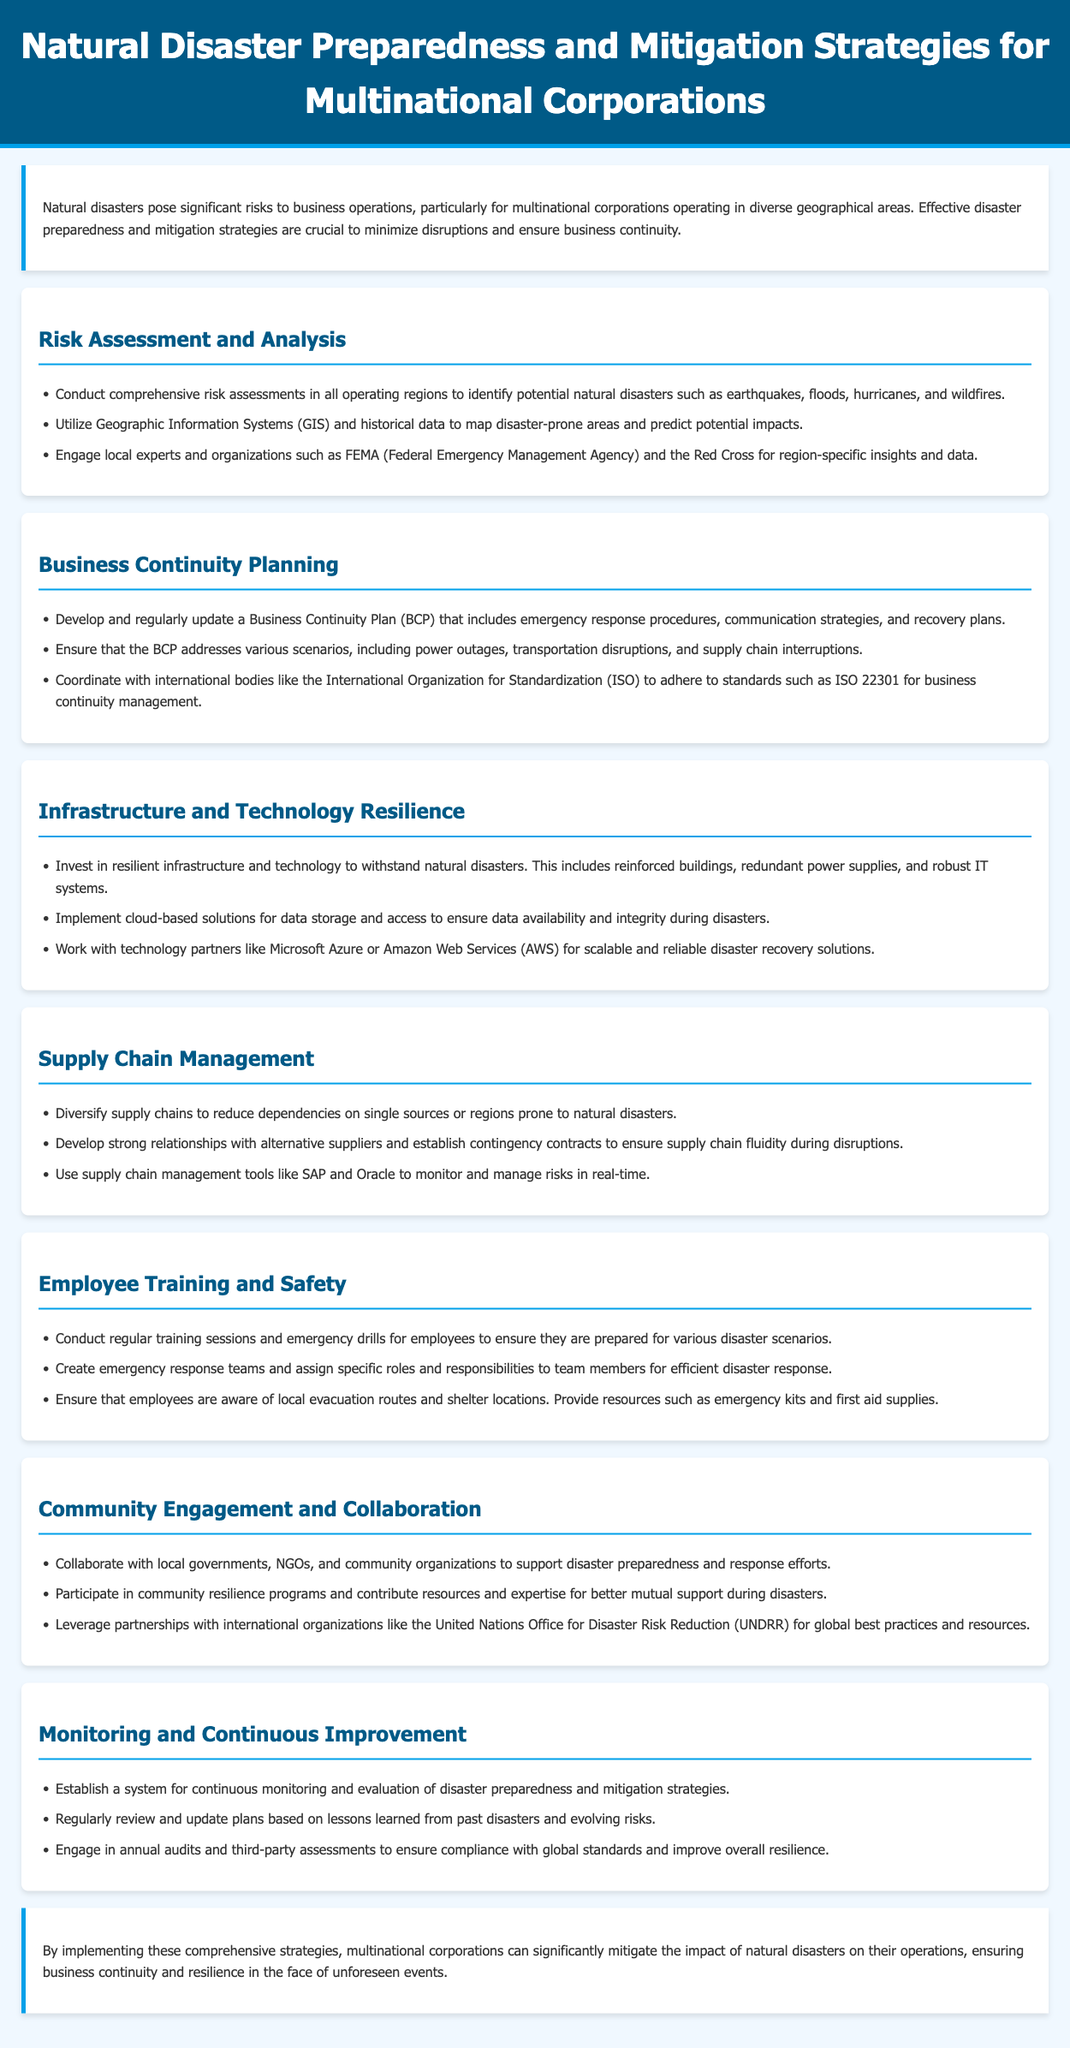what is the title of the document? The title can be found in the header section of the document.
Answer: Natural Disaster Preparedness and Mitigation Strategies for Multinational Corporations how many sections are dedicated to strategies in the document? The document lists various sections focused on different strategies for preparedness and mitigation.
Answer: Seven which organization is mentioned for adherence to business continuity management standards? The document mentions an international body that sets standards for business continuity management.
Answer: International Organization for Standardization what is the main focus of the "Risk Assessment and Analysis" section? This section describes actions to identify potential disasters in different regions.
Answer: Comprehensive risk assessments which cloud solutions are suggested for disaster recovery? The document recommends specific technology partners for cloud-based solutions.
Answer: Microsoft Azure or Amazon Web Services why is it important to diversify supply chains according to the document? This strategy aims to mitigate risks associated with dependencies on specific regions.
Answer: To reduce dependencies on single sources what is a key action mentioned under "Monitoring and Continuous Improvement"? The section outlines actions for continually enhancing disaster preparedness strategies.
Answer: Establish a system for continuous monitoring who should be engaged for regional insights and data in risk assessment? The document advises engaging local experts for specific information.
Answer: Local experts and organizations such as FEMA and the Red Cross what type of training is recommended for employees? This training helps prepare employees for various scenarios effectively.
Answer: Regular training sessions and emergency drills 